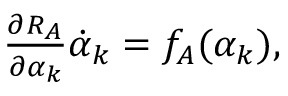<formula> <loc_0><loc_0><loc_500><loc_500>\begin{array} { r } { \frac { \partial R _ { A } } { \partial \alpha _ { k } } \dot { \alpha } _ { k } = f _ { A } ( \alpha _ { k } ) , } \end{array}</formula> 